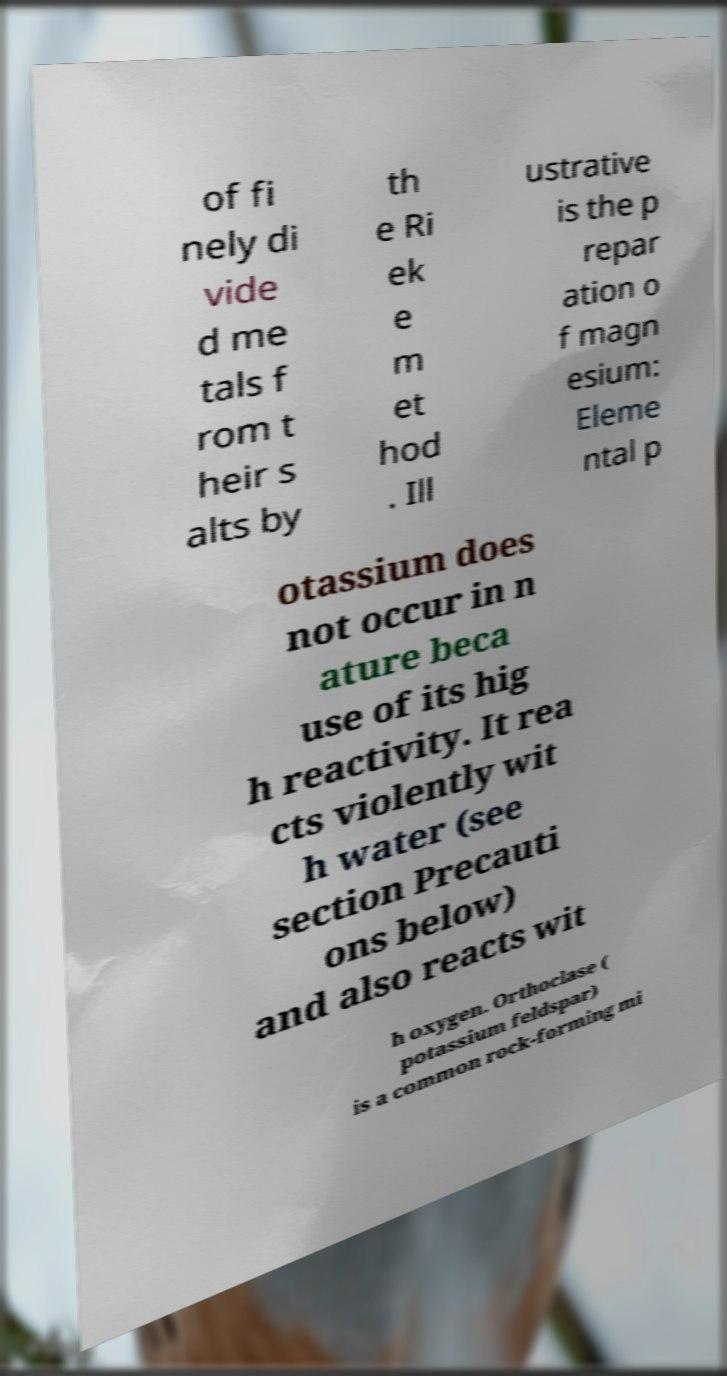I need the written content from this picture converted into text. Can you do that? of fi nely di vide d me tals f rom t heir s alts by th e Ri ek e m et hod . Ill ustrative is the p repar ation o f magn esium: Eleme ntal p otassium does not occur in n ature beca use of its hig h reactivity. It rea cts violently wit h water (see section Precauti ons below) and also reacts wit h oxygen. Orthoclase ( potassium feldspar) is a common rock-forming mi 